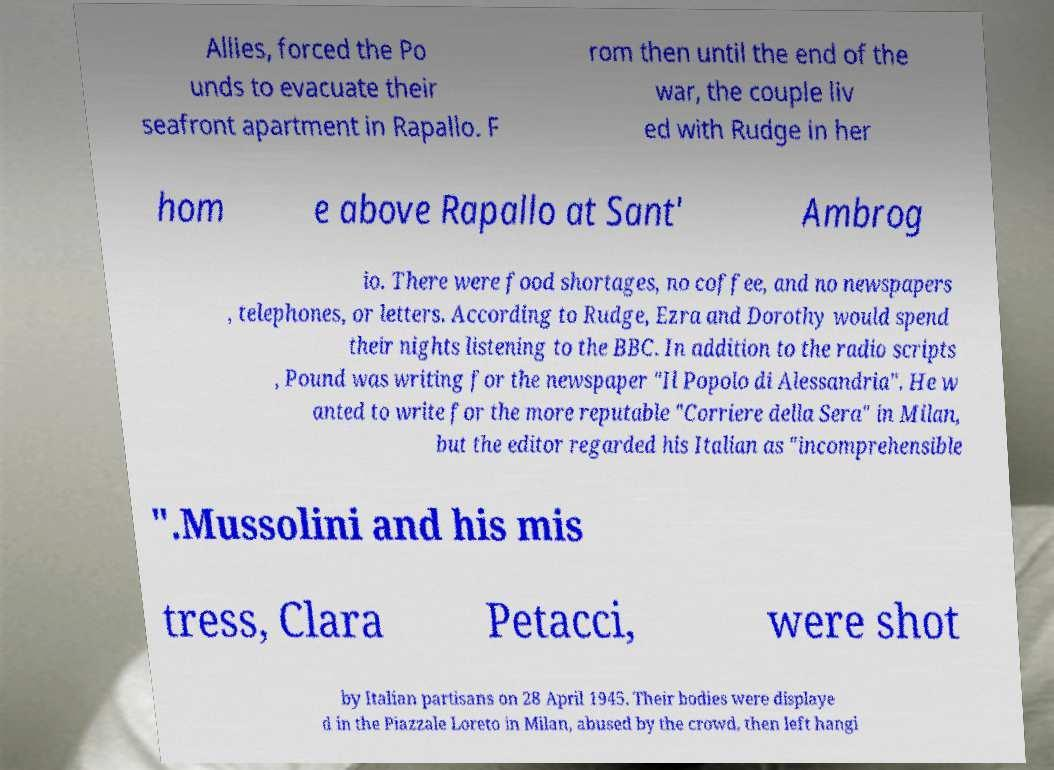Please identify and transcribe the text found in this image. Allies, forced the Po unds to evacuate their seafront apartment in Rapallo. F rom then until the end of the war, the couple liv ed with Rudge in her hom e above Rapallo at Sant' Ambrog io. There were food shortages, no coffee, and no newspapers , telephones, or letters. According to Rudge, Ezra and Dorothy would spend their nights listening to the BBC. In addition to the radio scripts , Pound was writing for the newspaper "Il Popolo di Alessandria". He w anted to write for the more reputable "Corriere della Sera" in Milan, but the editor regarded his Italian as "incomprehensible ".Mussolini and his mis tress, Clara Petacci, were shot by Italian partisans on 28 April 1945. Their bodies were displaye d in the Piazzale Loreto in Milan, abused by the crowd, then left hangi 